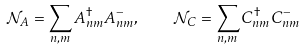Convert formula to latex. <formula><loc_0><loc_0><loc_500><loc_500>\mathcal { N } _ { A } = \sum _ { n , m } A _ { n m } ^ { \dagger } A _ { n m } ^ { - } , \quad \mathcal { N } _ { C } = \sum _ { n , m } C _ { n m } ^ { \dagger } C _ { n m } ^ { - }</formula> 